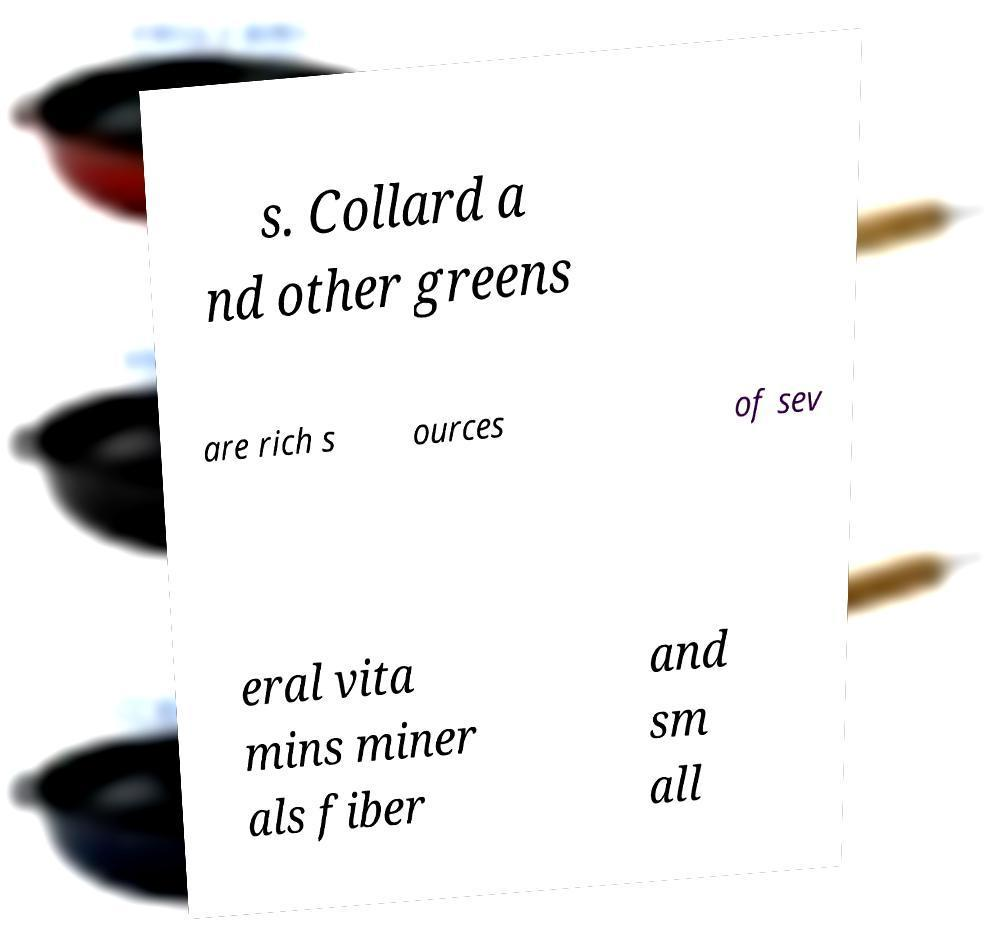Could you extract and type out the text from this image? s. Collard a nd other greens are rich s ources of sev eral vita mins miner als fiber and sm all 